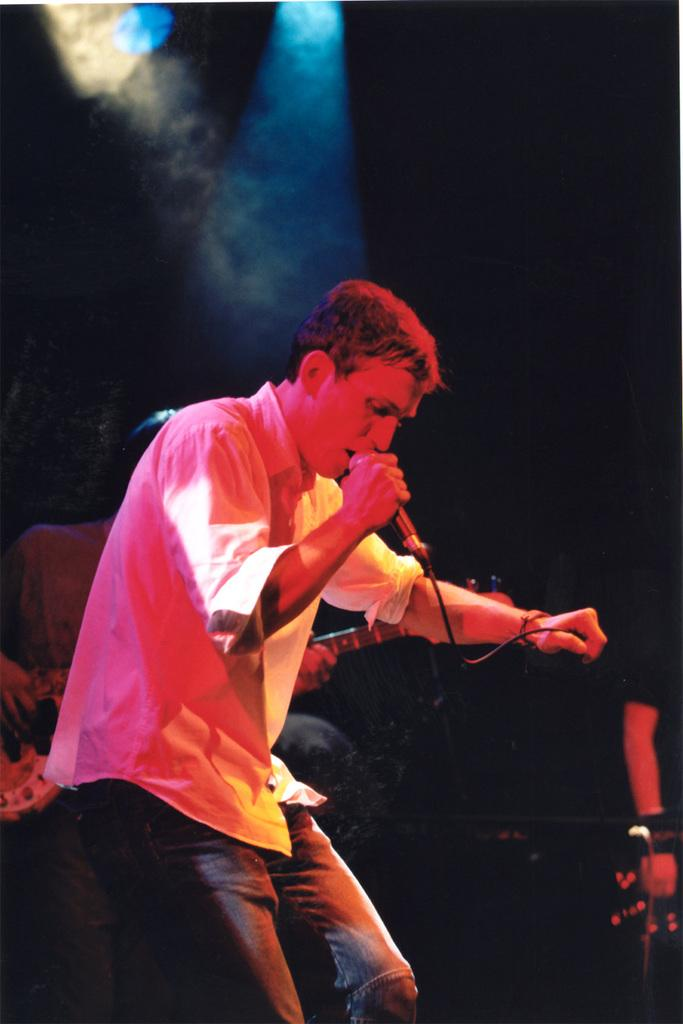What is the man in the image doing? The man is standing on a stage in the image. What is the man holding while on stage? The man is holding a microphone. What are the other people in the image doing? The other people in the image are playing musical instruments. What type of cake is being served on the slope in the image? There is no cake or slope present in the image. 